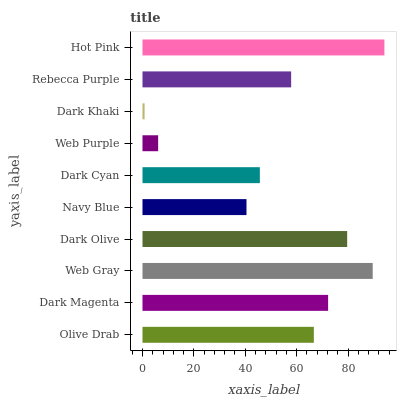Is Dark Khaki the minimum?
Answer yes or no. Yes. Is Hot Pink the maximum?
Answer yes or no. Yes. Is Dark Magenta the minimum?
Answer yes or no. No. Is Dark Magenta the maximum?
Answer yes or no. No. Is Dark Magenta greater than Olive Drab?
Answer yes or no. Yes. Is Olive Drab less than Dark Magenta?
Answer yes or no. Yes. Is Olive Drab greater than Dark Magenta?
Answer yes or no. No. Is Dark Magenta less than Olive Drab?
Answer yes or no. No. Is Olive Drab the high median?
Answer yes or no. Yes. Is Rebecca Purple the low median?
Answer yes or no. Yes. Is Navy Blue the high median?
Answer yes or no. No. Is Web Gray the low median?
Answer yes or no. No. 